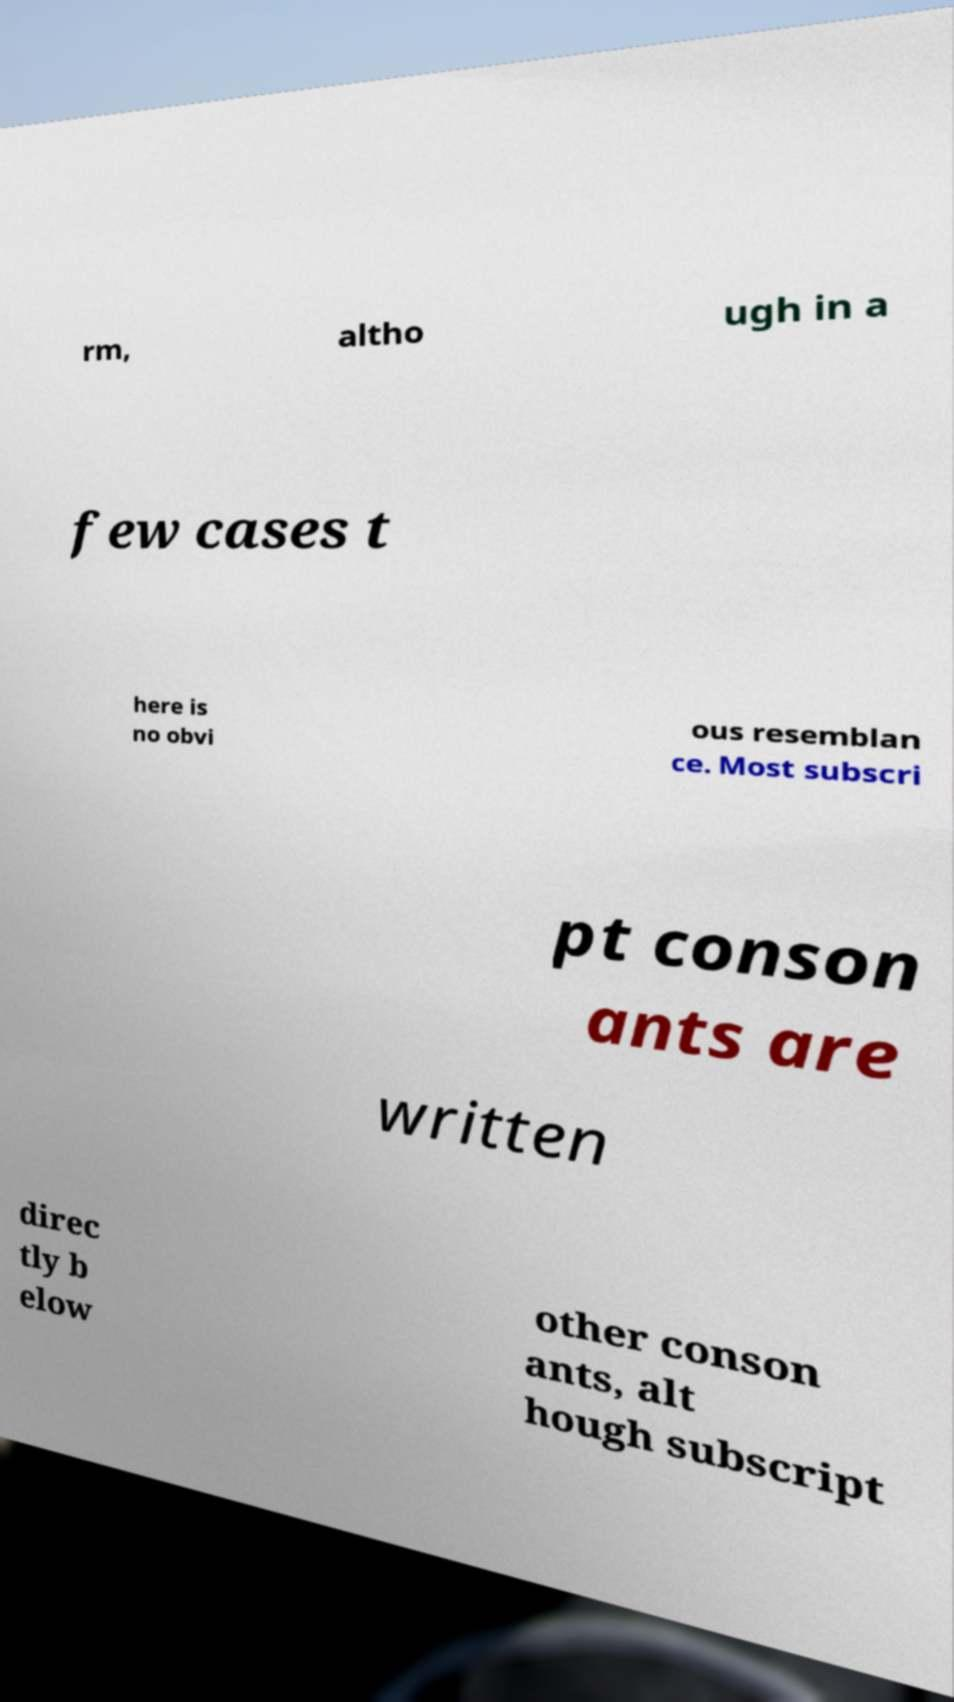Please identify and transcribe the text found in this image. rm, altho ugh in a few cases t here is no obvi ous resemblan ce. Most subscri pt conson ants are written direc tly b elow other conson ants, alt hough subscript 